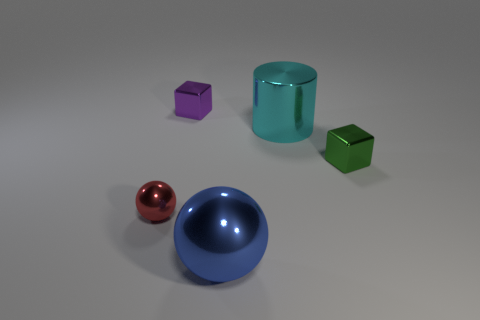Add 4 small purple metallic things. How many objects exist? 9 Subtract all spheres. How many objects are left? 3 Add 5 spheres. How many spheres exist? 7 Subtract 0 yellow balls. How many objects are left? 5 Subtract all green metallic things. Subtract all small red objects. How many objects are left? 3 Add 2 green shiny objects. How many green shiny objects are left? 3 